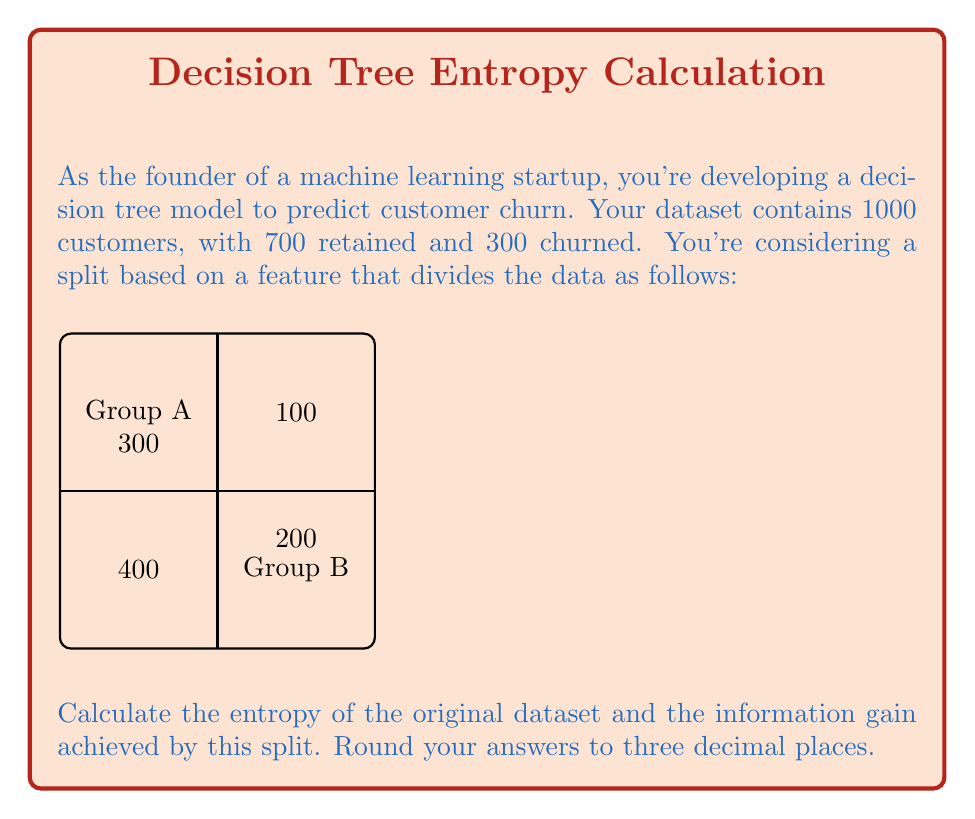Solve this math problem. Let's approach this step-by-step:

1. Calculate the entropy of the original dataset:
   - Total samples: 1000
   - Retained: 700, Churned: 300
   
   Entropy is calculated using the formula:
   $$H = -\sum_{i=1}^{n} p_i \log_2(p_i)$$
   
   $$H = -(\frac{700}{1000} \log_2(\frac{700}{1000}) + \frac{300}{1000} \log_2(\frac{300}{1000}))$$
   $$H = -(0.7 \log_2(0.7) + 0.3 \log_2(0.3))$$
   $$H = 0.881 \text{ bits}$$

2. Calculate the entropy for Group A:
   - Total in Group A: 700
   - Retained: 400, Churned: 300
   
   $$H_A = -(\frac{400}{700} \log_2(\frac{400}{700}) + \frac{300}{700} \log_2(\frac{300}{700}))$$
   $$H_A = 0.985 \text{ bits}$$

3. Calculate the entropy for Group B:
   - Total in Group B: 300
   - Retained: 300, Churned: 0
   
   $$H_B = -(\frac{300}{300} \log_2(\frac{300}{300}) + \frac{0}{300} \log_2(\frac{0}{300}))$$
   $$H_B = 0 \text{ bits}$$

4. Calculate the weighted average entropy after the split:
   $$H_{split} = \frac{700}{1000} H_A + \frac{300}{1000} H_B$$
   $$H_{split} = 0.7 * 0.985 + 0.3 * 0 = 0.690 \text{ bits}$$

5. Calculate the information gain:
   $$IG = H_{original} - H_{split}$$
   $$IG = 0.881 - 0.690 = 0.191 \text{ bits}$$
Answer: Entropy of original dataset: 0.881 bits
Information gain: 0.191 bits 